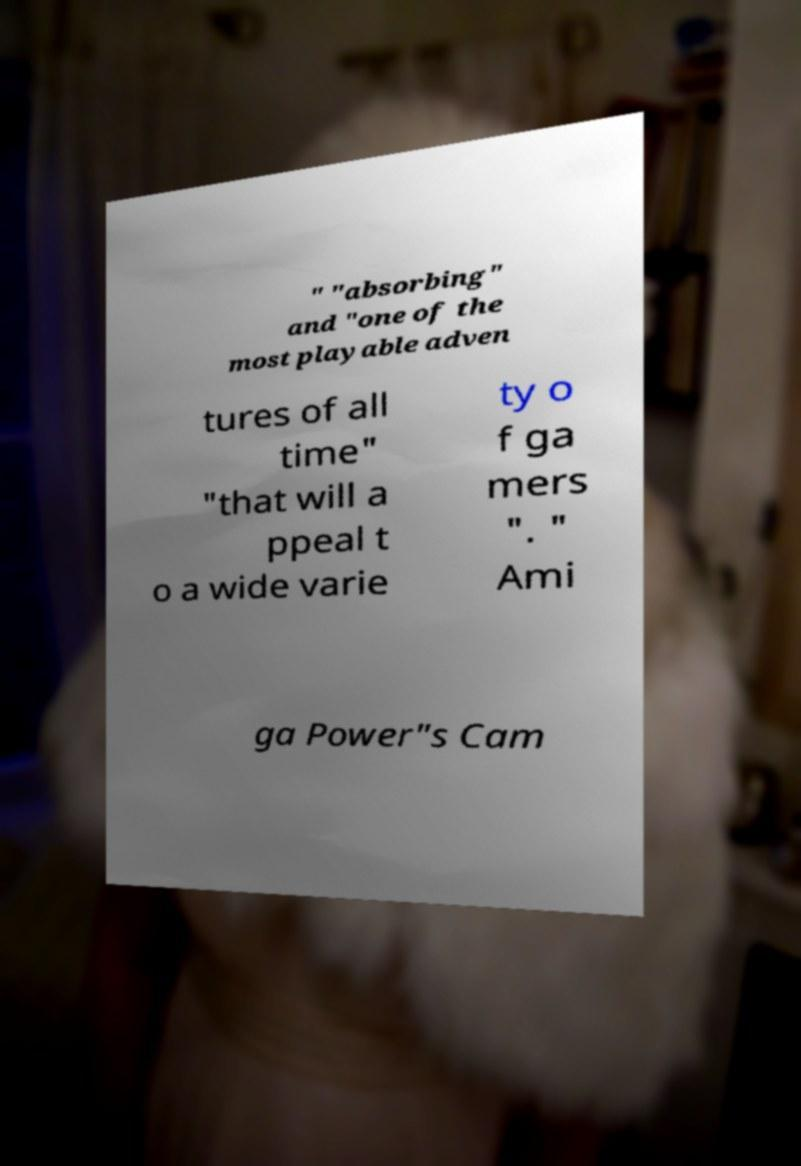Could you extract and type out the text from this image? " "absorbing" and "one of the most playable adven tures of all time" "that will a ppeal t o a wide varie ty o f ga mers ". " Ami ga Power"s Cam 